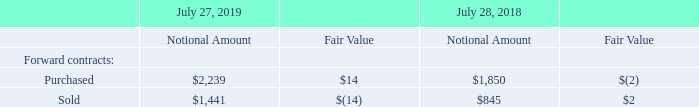Foreign Currency Exchange Risk
Our foreign exchange forward contracts outstanding at fiscal year-end are summarized in U.S. dollar equivalents as follows (in millions):
At July 27, 2019 and July 28, 2018, we had no option contracts outstanding.
We conduct business globally in numerous currencies. The direct effect of foreign currency fluctuations on revenue has not been material because our revenue is primarily denominated in U.S. dollars. However, if the U.S. dollar strengthens relative to other currencies, such strengthening could have an indirect effect on our revenue to the extent it raises the cost of our products to non-U.S. customers and thereby reduces demand. A weaker U.S. dollar could have the opposite effect. However, the precise indirect effect of currency fluctuations is difficult to measure or predict because our revenue is influenced by many factors in addition to the impact of such currency fluctuations
Approximately 70% of our operating expenses are U.S.-dollar denominated. In fiscal 2019, foreign currency fluctuations, net of hedging, decreased our combined R&D, sales and marketing, and G&A expenses by approximately $233 million, or 1.3%, as compared with fiscal 2018. In fiscal 2018, foreign currency fluctuations, net of hedging, increased our combined R&D, sales and marketing, and G&A expenses by approximately $93 million, or 0.5%, as compared with fiscal 2017. To reduce variability in operating expenses and service cost of sales caused by non-U.S.-dollar denominated operating expenses and costs, we may hedge certain forecasted foreign currency transactions with currency options and forward contracts. These hedging programs are not designed to provide foreign currency protection over long time horizons. In designing a specific hedging approach, we consider several factors, including offsetting exposures, significance of exposures, costs associated with entering into a particular hedge instrument, and potential effectiveness of the hedge. The gains and losses on foreign exchange contracts mitigate the effect of currency movements on our operating expenses and service cost of sales.
We also enter into foreign exchange forward and option contracts to reduce the short-term effects of foreign currency fluctuations on receivables and payables that are denominated in currencies other than the functional currencies of the entities. The market risks associated with these foreign currency receivables, investments, and payables relate primarily to variances from our forecasted foreign currency transactions and balances. We do not enter into foreign exchange forward or option contracts for speculative purposes
Which years does the table provide information for the company's foreign exchange forward contracts outstanding at fiscal year-end? 2019, 2018. Why has the direct effect of foreign currency fluctuations on revenue not been material? Because our revenue is primarily denominated in u.s. dollars. What was the Fair value of purchased forward contracts in 2019?
Answer scale should be: million. 14. What was the change in the notional amount of purchased forward contracts between 2018 and 2019?
Answer scale should be: million. 2,239-1,850
Answer: 389. What was the change in the fair value of sold forward contracts between 2018 and 2019?
Answer scale should be: million. -14-2
Answer: -16. What was the percentage change in the notional amount of sold forward contracts between 2018 and 2019?
Answer scale should be: percent. (1,441-845)/845
Answer: 70.53. 